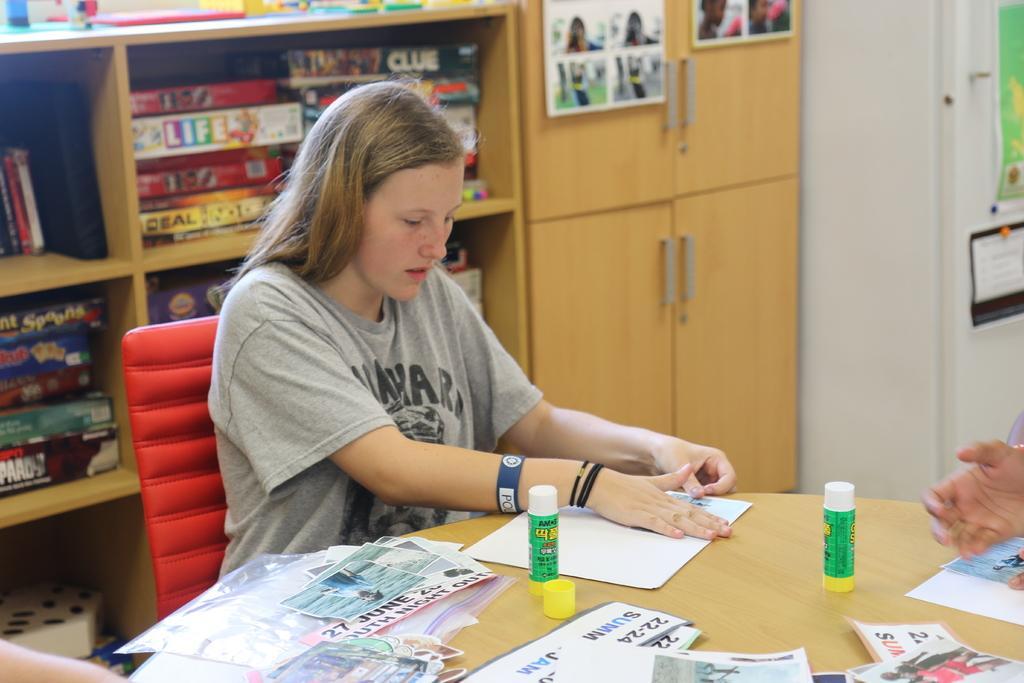Describe this image in one or two sentences. In this image there is a woman sitting on a chair. In front of her there is a table. There are papers and glue sticks on the table. Behind her there are cupboards. There are boxes in the cupboards. There are pictures sticked on the walls of the cupboard. To the right there is a wall. In the bottom right there is a hand of a person. 